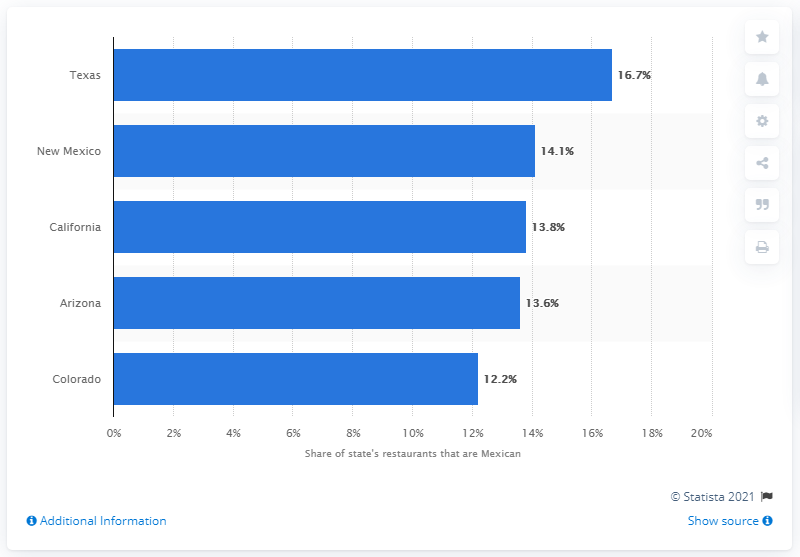Highlight a few significant elements in this photo. In Texas, approximately 16.7% of restaurants serve Mexican cuisine. 